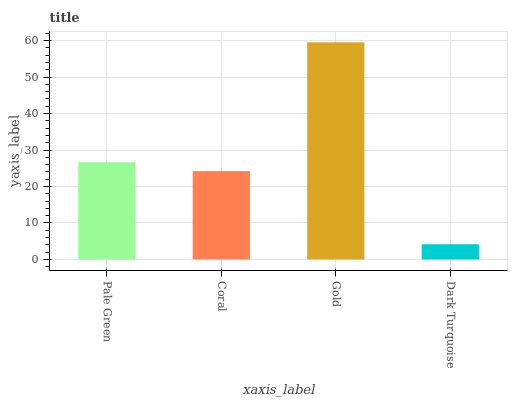Is Dark Turquoise the minimum?
Answer yes or no. Yes. Is Gold the maximum?
Answer yes or no. Yes. Is Coral the minimum?
Answer yes or no. No. Is Coral the maximum?
Answer yes or no. No. Is Pale Green greater than Coral?
Answer yes or no. Yes. Is Coral less than Pale Green?
Answer yes or no. Yes. Is Coral greater than Pale Green?
Answer yes or no. No. Is Pale Green less than Coral?
Answer yes or no. No. Is Pale Green the high median?
Answer yes or no. Yes. Is Coral the low median?
Answer yes or no. Yes. Is Coral the high median?
Answer yes or no. No. Is Pale Green the low median?
Answer yes or no. No. 